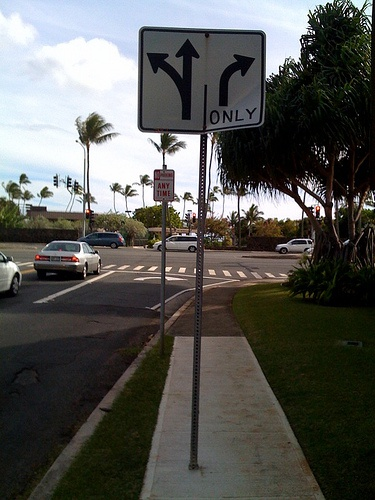Describe the objects in this image and their specific colors. I can see car in lavender, black, gray, darkgray, and lightgray tones, car in lavender, black, gray, darkgray, and ivory tones, car in lavender, black, darkgray, and gray tones, car in lavender, black, gray, and darkblue tones, and car in lavender, black, darkgray, gray, and lightgray tones in this image. 